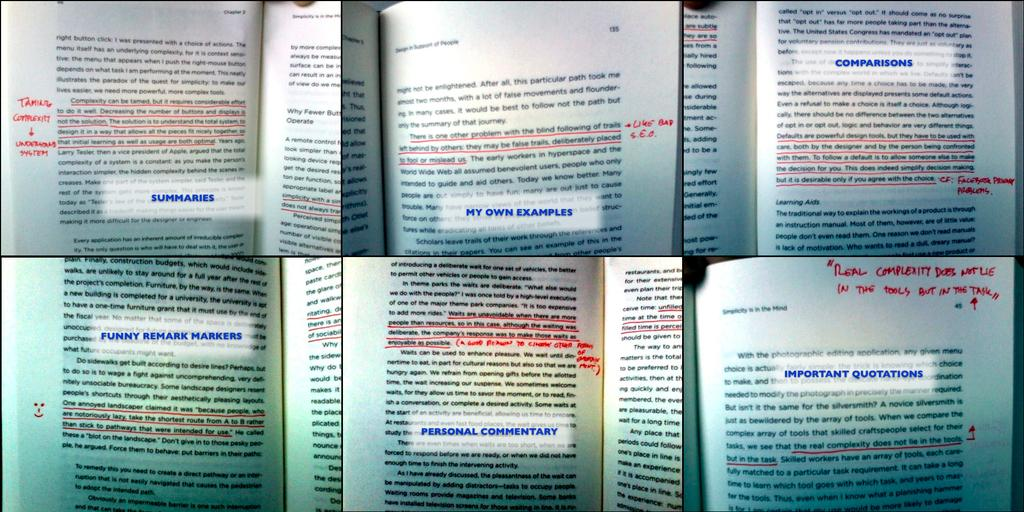<image>
Relay a brief, clear account of the picture shown. You can find everything from Summaries to Important Quotations in the open pages of this book. 